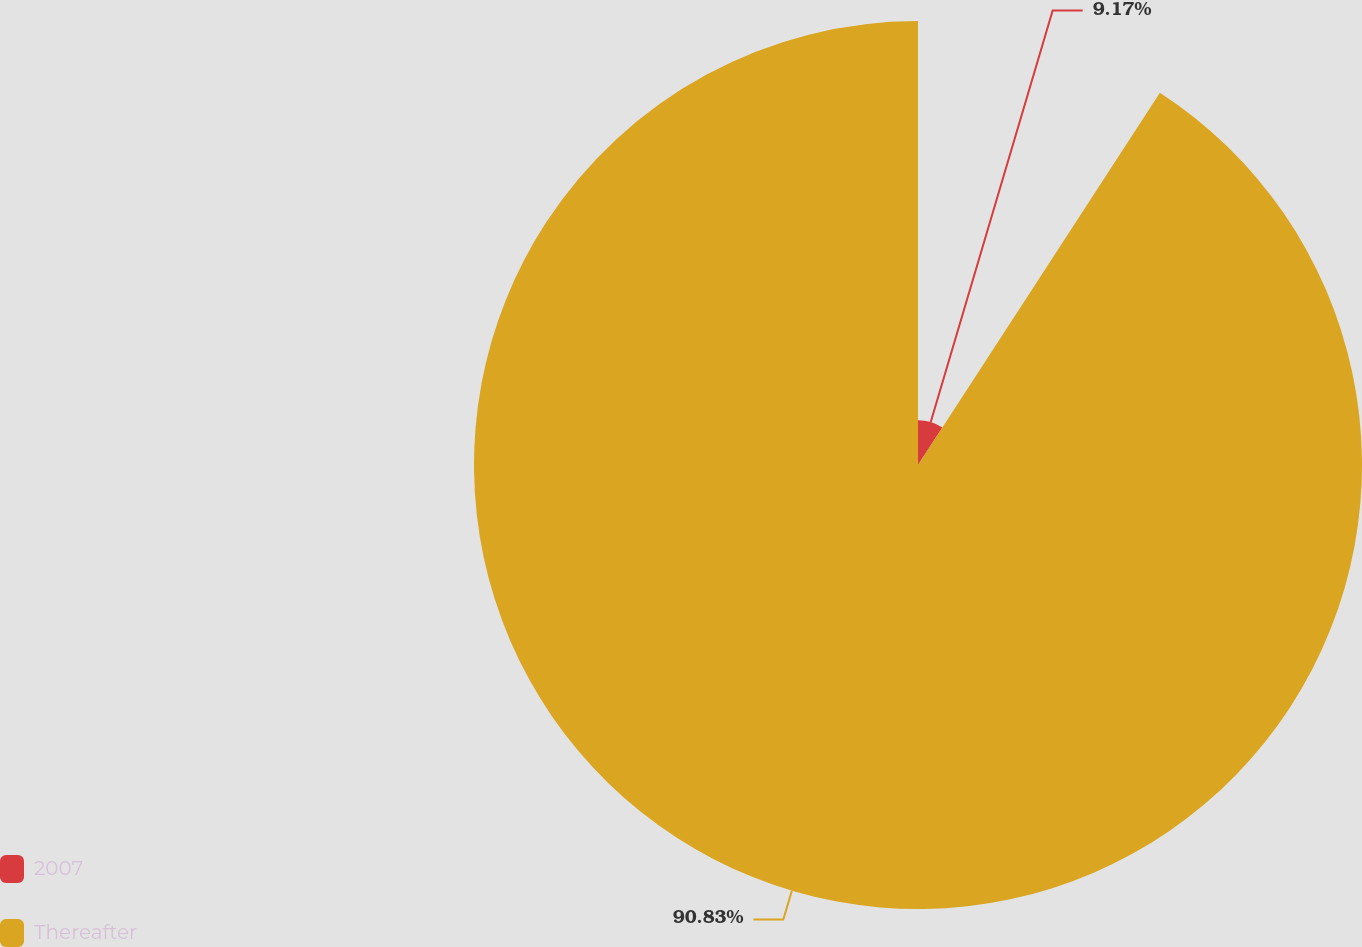Convert chart. <chart><loc_0><loc_0><loc_500><loc_500><pie_chart><fcel>2007<fcel>Thereafter<nl><fcel>9.17%<fcel>90.83%<nl></chart> 